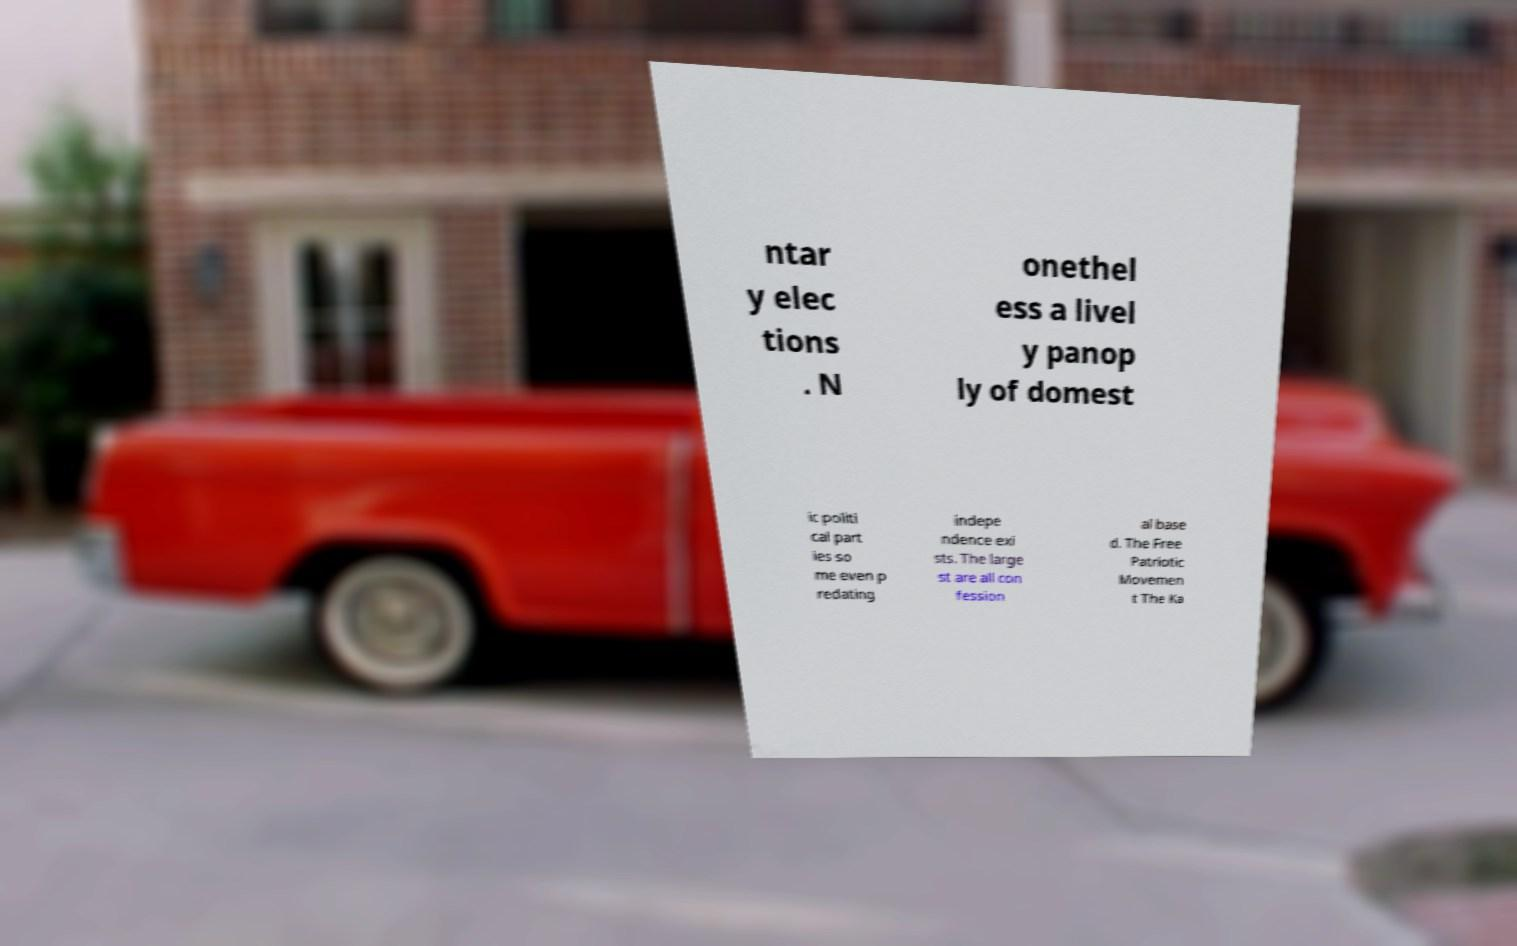There's text embedded in this image that I need extracted. Can you transcribe it verbatim? ntar y elec tions . N onethel ess a livel y panop ly of domest ic politi cal part ies so me even p redating indepe ndence exi sts. The large st are all con fession al base d. The Free Patriotic Movemen t The Ka 